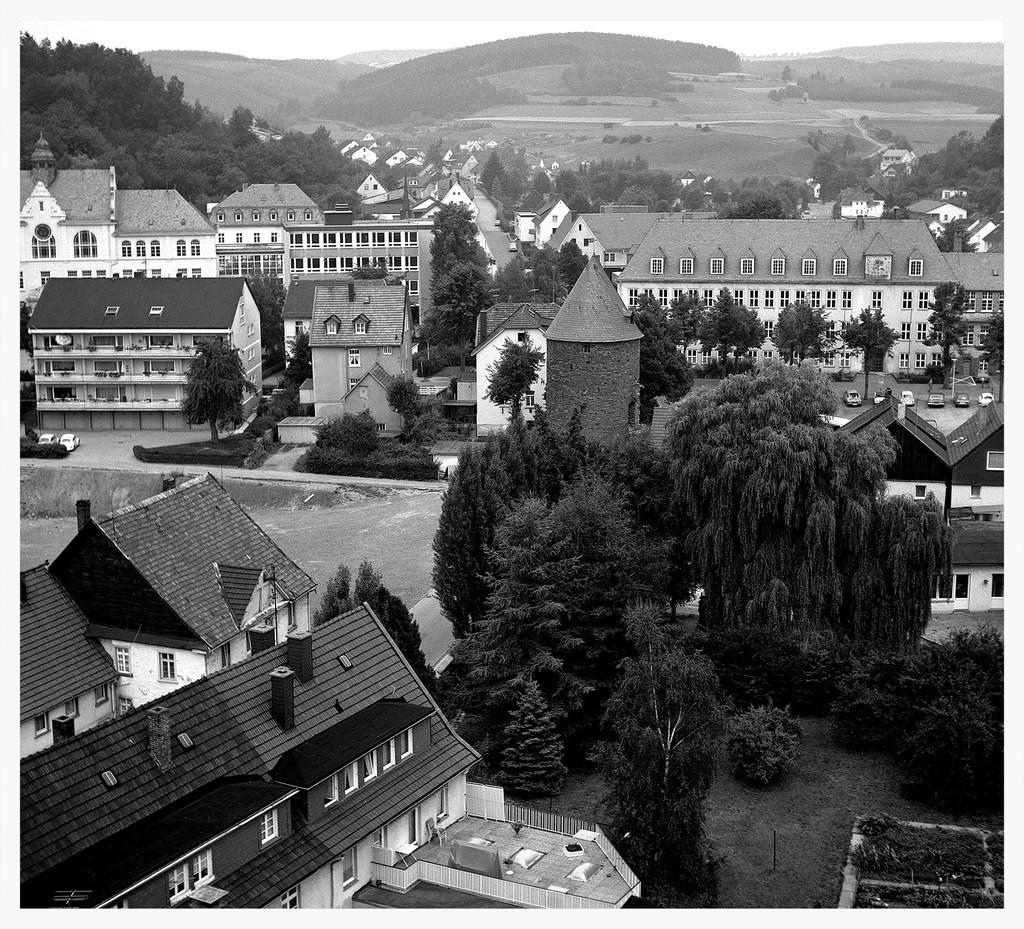What is the color scheme of the image? The image is black and white. What types of structures can be seen in the image? There are buildings in the image. What type of vegetation is present in the image? There are trees, plants, and grass in the image. What mode of transportation can be seen in the image? There are vehicles in the image. What parts of the natural environment are visible in the image? A: Ground and sky are visible in the image. What book is the person reading in the image? There is no person or book present in the image; it only contains buildings, trees, plants, grass, vehicles, ground, and sky. 